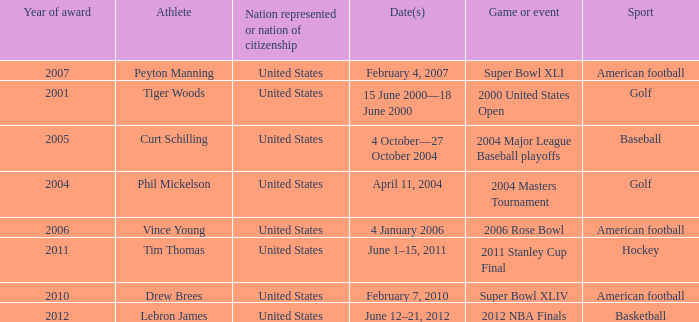In 2011 which sport had the year award? Hockey. 